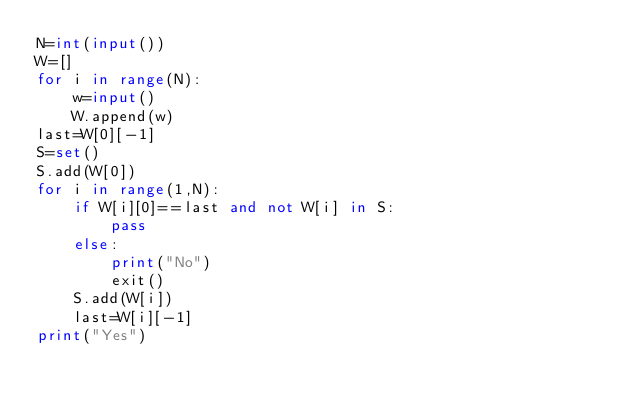<code> <loc_0><loc_0><loc_500><loc_500><_Python_>N=int(input())
W=[]
for i in range(N):
    w=input()
    W.append(w)
last=W[0][-1]
S=set()
S.add(W[0])
for i in range(1,N):
    if W[i][0]==last and not W[i] in S:
        pass
    else:
        print("No")
        exit()
    S.add(W[i])
    last=W[i][-1]
print("Yes")</code> 